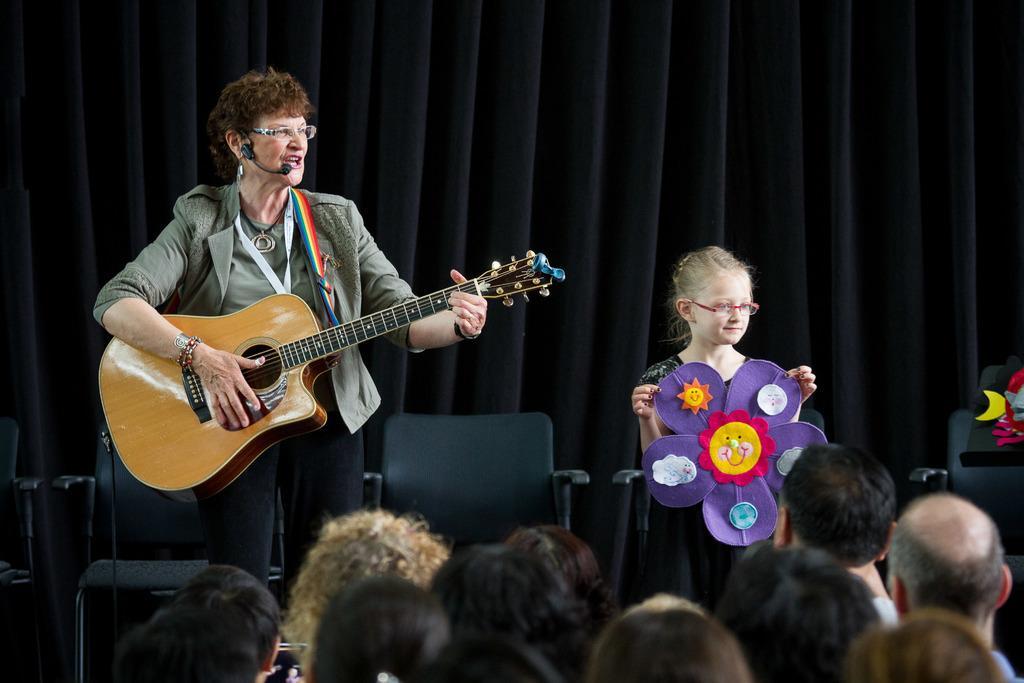Could you give a brief overview of what you see in this image? This woman is standing and plays a guitar. This girl is standing and holds a craft. This are chairs in black color. This is a black curtain. This are audience. This woman wore spectacles and mic. 